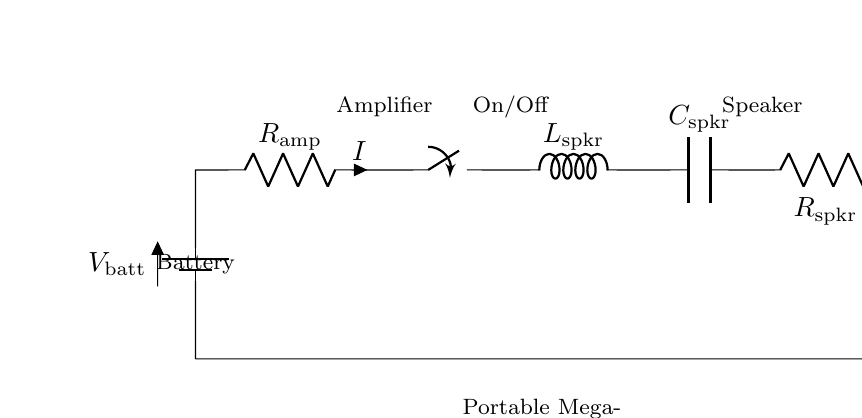What is the total current in this circuit? The total current is represented by 'I' in the diagram, which is flowing through the amplifier and other components in series. To find it, you would need to apply Ohm's Law using the effective resistance and voltage specified, but the specific values are not provided in the diagram.
Answer: I What is the component connected at the beginning of the circuit? The component connected at the beginning is the battery, indicated by the symbol 'V_batt'. This supplies power to the entire circuit.
Answer: Battery What is the function of the switch in this circuit? The switch in the circuit acts as an on/off mechanism, allowing the user to control when the current flows through the circuit. When open, the circuit is incomplete, stopping current flow. When closed, it allows current to flow to the subsequent components.
Answer: Control current What is the purpose of the amplifier in this circuit? The amplifier serves to increase the amplitude of the audio signal coming from the microphone, so the output to the speaker is of sufficient volume for a protest setting. It is crucial for ensuring that messages can be heard over a larger distance.
Answer: Increase volume What components are in series in this circuit configuration? In this circuit, the battery, amplifier, switch, speaker, capacitor, and speaker resistor are all connected in series, meaning that they share the same current and the voltage is divided among them as per their resistances and reactances.
Answer: Battery, amplifier, switch, speaker, capacitor, resistor What is the role of the capacitor in the circuit? The capacitor's role is to smooth out the electrical signals and filter any unwanted noise, ensuring that the output sound from the speaker is clearer and more consistent, which is important during protests where clarity is essential.
Answer: Filter noise 